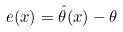Convert formula to latex. <formula><loc_0><loc_0><loc_500><loc_500>e ( x ) = \hat { \theta } ( x ) - \theta</formula> 